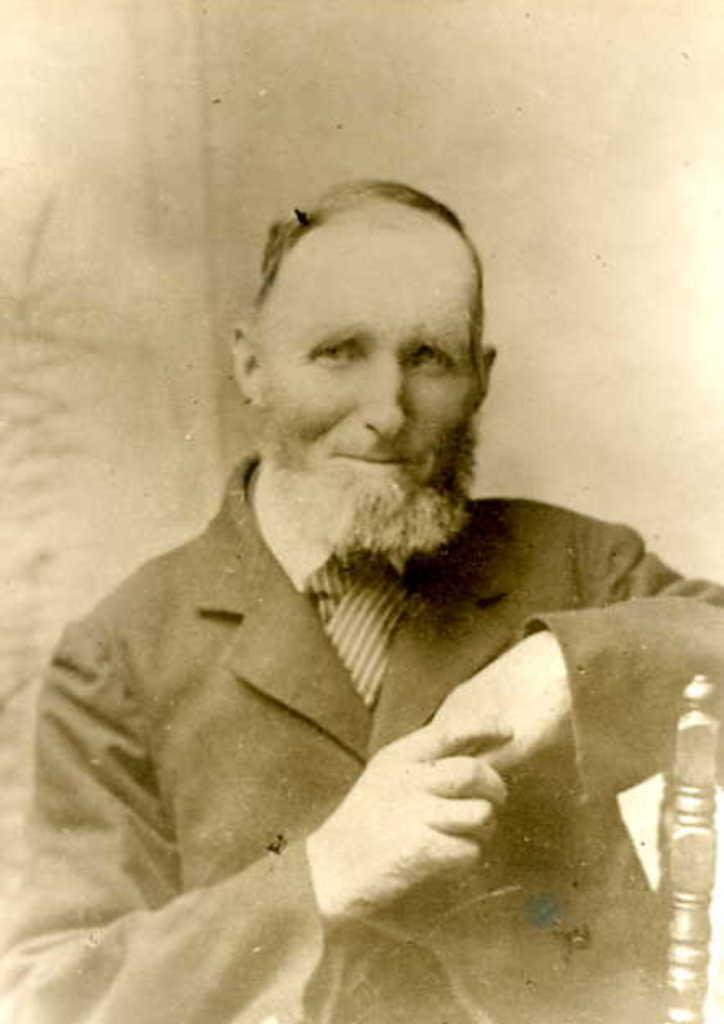What is the main subject of the image? There is a person in the image. What color scheme is used in the image? The image is in black and white. How many squares can be seen in the image? There are no squares present in the image. What type of ear is visible on the person in the image? The image is in black and white, so it is not possible to determine the type of ear visible on the person. 